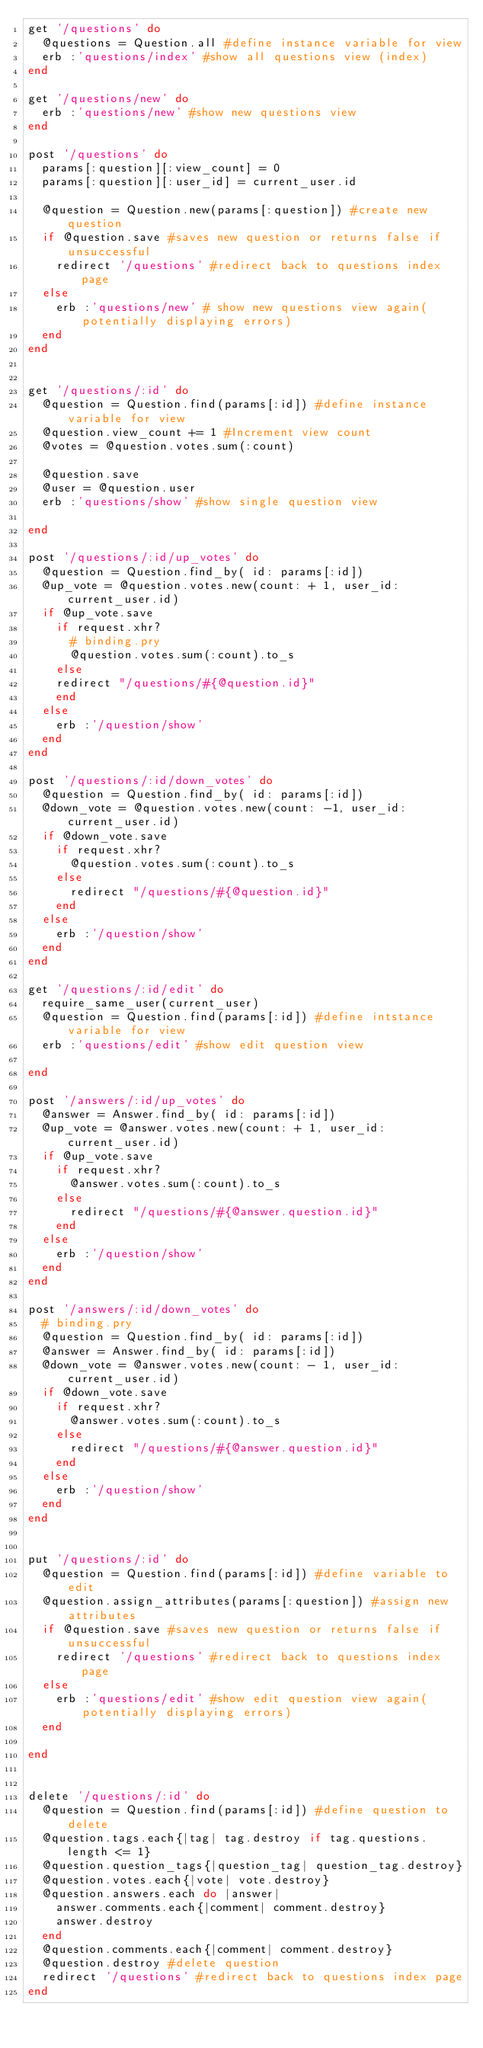Convert code to text. <code><loc_0><loc_0><loc_500><loc_500><_Ruby_>get '/questions' do
  @questions = Question.all #define instance variable for view
  erb :'questions/index' #show all questions view (index)
end

get '/questions/new' do
  erb :'questions/new' #show new questions view
end

post '/questions' do
  params[:question][:view_count] = 0
  params[:question][:user_id] = current_user.id

  @question = Question.new(params[:question]) #create new question
  if @question.save #saves new question or returns false if unsuccessful
    redirect '/questions' #redirect back to questions index page
  else
    erb :'questions/new' # show new questions view again(potentially displaying errors)
  end
end


get '/questions/:id' do
  @question = Question.find(params[:id]) #define instance variable for view
  @question.view_count += 1 #Increment view count
  @votes = @question.votes.sum(:count)

  @question.save
  @user = @question.user
  erb :'questions/show' #show single question view

end

post '/questions/:id/up_votes' do
  @question = Question.find_by( id: params[:id])
  @up_vote = @question.votes.new(count: + 1, user_id: current_user.id)
  if @up_vote.save
    if request.xhr?
      # binding.pry
      @question.votes.sum(:count).to_s
    else
    redirect "/questions/#{@question.id}"
    end
  else
    erb :'/question/show'
  end
end

post '/questions/:id/down_votes' do
  @question = Question.find_by( id: params[:id])
  @down_vote = @question.votes.new(count: -1, user_id: current_user.id)
  if @down_vote.save
    if request.xhr?
      @question.votes.sum(:count).to_s
    else
      redirect "/questions/#{@question.id}"
    end
  else
    erb :'/question/show'
  end
end

get '/questions/:id/edit' do
  require_same_user(current_user)
  @question = Question.find(params[:id]) #define intstance variable for view
  erb :'questions/edit' #show edit question view

end

post '/answers/:id/up_votes' do
  @answer = Answer.find_by( id: params[:id])
  @up_vote = @answer.votes.new(count: + 1, user_id: current_user.id)
  if @up_vote.save
    if request.xhr?
      @answer.votes.sum(:count).to_s
    else
      redirect "/questions/#{@answer.question.id}"
    end
  else
    erb :'/question/show'
  end
end

post '/answers/:id/down_votes' do
  # binding.pry
  @question = Question.find_by( id: params[:id])
  @answer = Answer.find_by( id: params[:id])
  @down_vote = @answer.votes.new(count: - 1, user_id: current_user.id)
  if @down_vote.save
    if request.xhr?
      @answer.votes.sum(:count).to_s
    else
      redirect "/questions/#{@answer.question.id}"
    end
  else
    erb :'/question/show'
  end
end


put '/questions/:id' do
  @question = Question.find(params[:id]) #define variable to edit
  @question.assign_attributes(params[:question]) #assign new attributes
  if @question.save #saves new question or returns false if unsuccessful
    redirect '/questions' #redirect back to questions index page
  else
    erb :'questions/edit' #show edit question view again(potentially displaying errors)
  end

end


delete '/questions/:id' do
  @question = Question.find(params[:id]) #define question to delete
  @question.tags.each{|tag| tag.destroy if tag.questions.length <= 1}
  @question.question_tags{|question_tag| question_tag.destroy}
  @question.votes.each{|vote| vote.destroy}
  @question.answers.each do |answer|
    answer.comments.each{|comment| comment.destroy}
    answer.destroy
  end
  @question.comments.each{|comment| comment.destroy}
  @question.destroy #delete question
  redirect '/questions' #redirect back to questions index page
end
</code> 